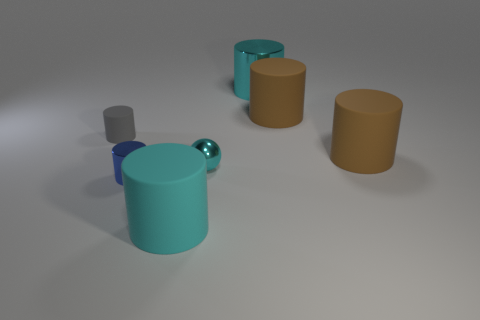Subtract all blue cylinders. How many cylinders are left? 5 Subtract all tiny gray cylinders. How many cylinders are left? 5 Subtract all blue cylinders. Subtract all gray blocks. How many cylinders are left? 5 Add 2 tiny cyan shiny balls. How many objects exist? 9 Subtract all cylinders. How many objects are left? 1 Subtract 0 red cylinders. How many objects are left? 7 Subtract all cyan rubber things. Subtract all big cyan metal cylinders. How many objects are left? 5 Add 2 tiny cylinders. How many tiny cylinders are left? 4 Add 4 cyan rubber cylinders. How many cyan rubber cylinders exist? 5 